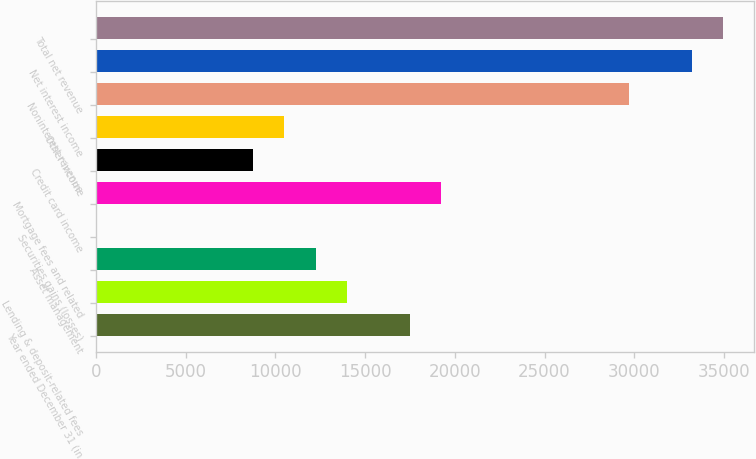Convert chart. <chart><loc_0><loc_0><loc_500><loc_500><bar_chart><fcel>Year ended December 31 (in<fcel>Lending & deposit-related fees<fcel>Asset management<fcel>Securities gains (losses)<fcel>Mortgage fees and related<fcel>Credit card income<fcel>Other income<fcel>Noninterest revenue<fcel>Net interest income<fcel>Total net revenue<nl><fcel>17479<fcel>13983.4<fcel>12235.6<fcel>1<fcel>19226.8<fcel>8740<fcel>10487.8<fcel>29713.6<fcel>33209.2<fcel>34957<nl></chart> 